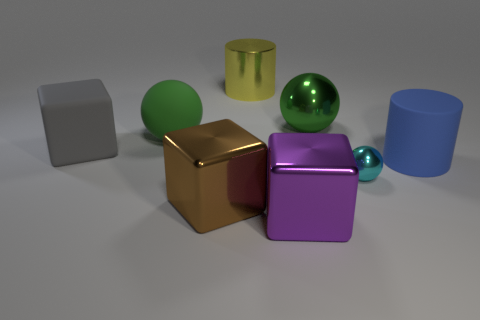What materials are the objects in the image likely made of? The objects in the image appear to have different materials based on their surface properties. The matte surfaces suggest a non-reflective material, like plastic or painted metal, while the shiny objects could be made of polished metal or glass due to their reflective and glossy nature. 